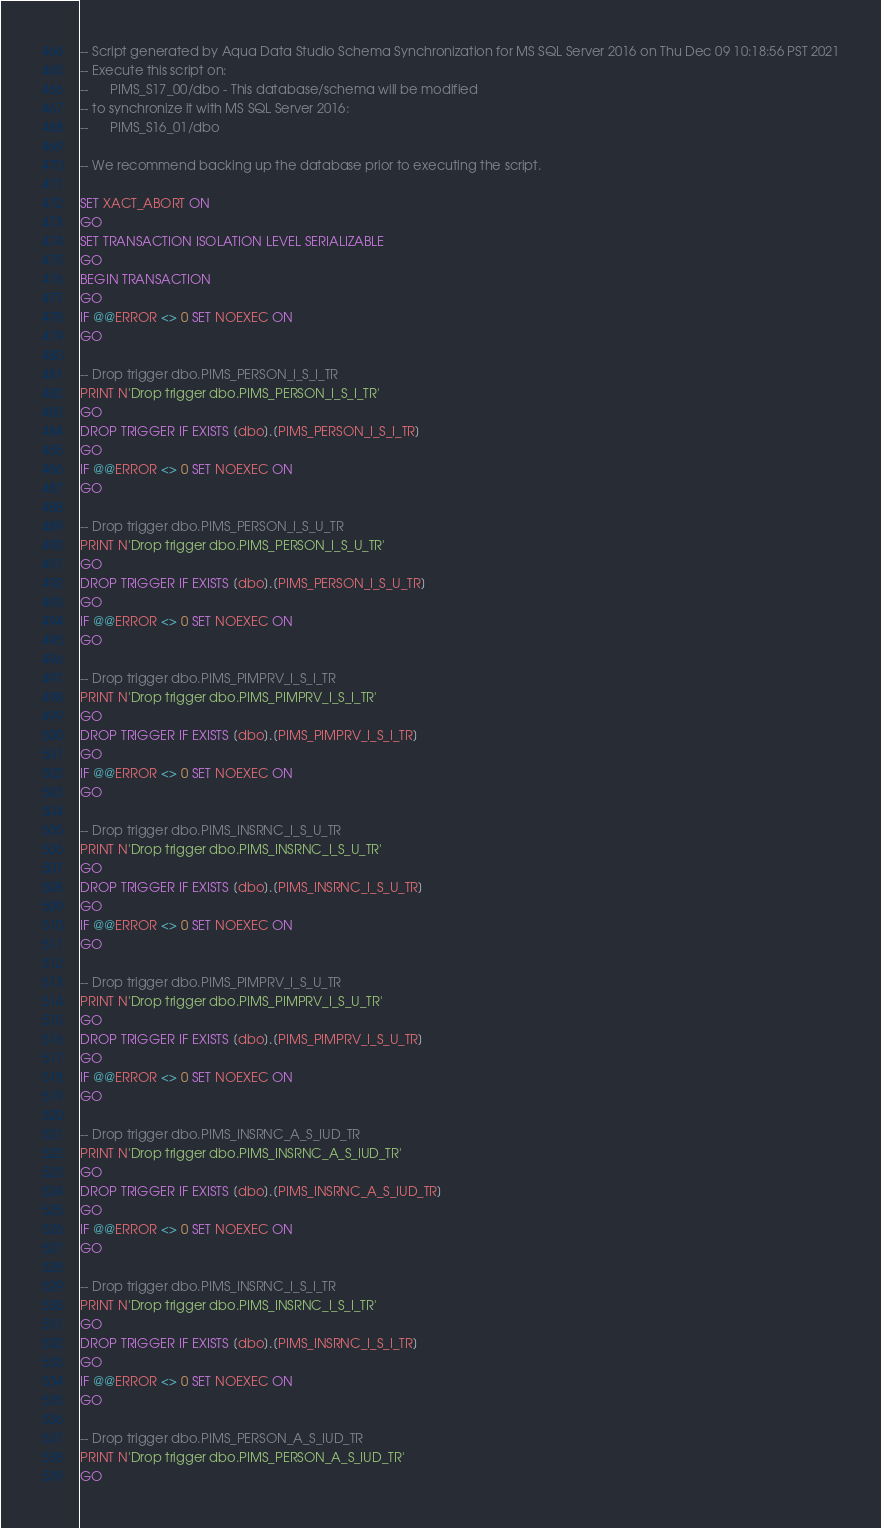Convert code to text. <code><loc_0><loc_0><loc_500><loc_500><_SQL_>-- Script generated by Aqua Data Studio Schema Synchronization for MS SQL Server 2016 on Thu Dec 09 10:18:56 PST 2021
-- Execute this script on:
-- 		PIMS_S17_00/dbo - This database/schema will be modified
-- to synchronize it with MS SQL Server 2016:
-- 		PIMS_S16_01/dbo

-- We recommend backing up the database prior to executing the script.

SET XACT_ABORT ON
GO
SET TRANSACTION ISOLATION LEVEL SERIALIZABLE
GO
BEGIN TRANSACTION
GO
IF @@ERROR <> 0 SET NOEXEC ON
GO

-- Drop trigger dbo.PIMS_PERSON_I_S_I_TR
PRINT N'Drop trigger dbo.PIMS_PERSON_I_S_I_TR'
GO
DROP TRIGGER IF EXISTS [dbo].[PIMS_PERSON_I_S_I_TR]
GO
IF @@ERROR <> 0 SET NOEXEC ON
GO

-- Drop trigger dbo.PIMS_PERSON_I_S_U_TR
PRINT N'Drop trigger dbo.PIMS_PERSON_I_S_U_TR'
GO
DROP TRIGGER IF EXISTS [dbo].[PIMS_PERSON_I_S_U_TR]
GO
IF @@ERROR <> 0 SET NOEXEC ON
GO

-- Drop trigger dbo.PIMS_PIMPRV_I_S_I_TR
PRINT N'Drop trigger dbo.PIMS_PIMPRV_I_S_I_TR'
GO
DROP TRIGGER IF EXISTS [dbo].[PIMS_PIMPRV_I_S_I_TR]
GO
IF @@ERROR <> 0 SET NOEXEC ON
GO

-- Drop trigger dbo.PIMS_INSRNC_I_S_U_TR
PRINT N'Drop trigger dbo.PIMS_INSRNC_I_S_U_TR'
GO
DROP TRIGGER IF EXISTS [dbo].[PIMS_INSRNC_I_S_U_TR]
GO
IF @@ERROR <> 0 SET NOEXEC ON
GO

-- Drop trigger dbo.PIMS_PIMPRV_I_S_U_TR
PRINT N'Drop trigger dbo.PIMS_PIMPRV_I_S_U_TR'
GO
DROP TRIGGER IF EXISTS [dbo].[PIMS_PIMPRV_I_S_U_TR]
GO
IF @@ERROR <> 0 SET NOEXEC ON
GO

-- Drop trigger dbo.PIMS_INSRNC_A_S_IUD_TR
PRINT N'Drop trigger dbo.PIMS_INSRNC_A_S_IUD_TR'
GO
DROP TRIGGER IF EXISTS [dbo].[PIMS_INSRNC_A_S_IUD_TR]
GO
IF @@ERROR <> 0 SET NOEXEC ON
GO

-- Drop trigger dbo.PIMS_INSRNC_I_S_I_TR
PRINT N'Drop trigger dbo.PIMS_INSRNC_I_S_I_TR'
GO
DROP TRIGGER IF EXISTS [dbo].[PIMS_INSRNC_I_S_I_TR]
GO
IF @@ERROR <> 0 SET NOEXEC ON
GO

-- Drop trigger dbo.PIMS_PERSON_A_S_IUD_TR
PRINT N'Drop trigger dbo.PIMS_PERSON_A_S_IUD_TR'
GO</code> 